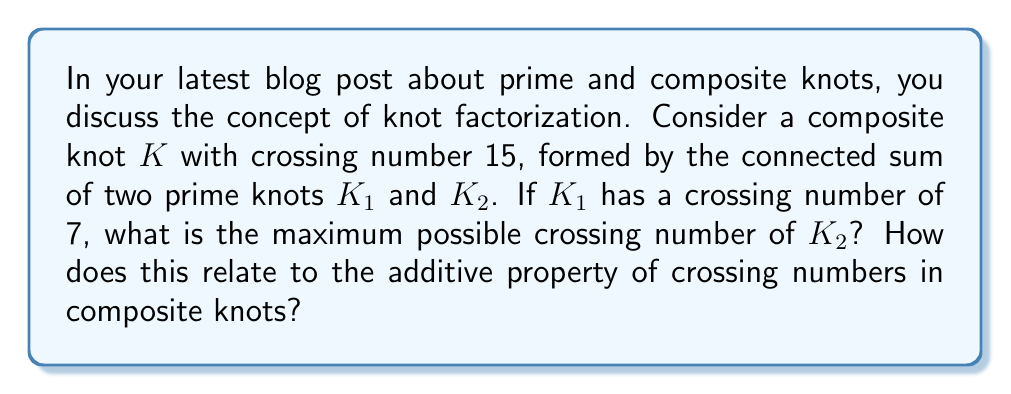What is the answer to this math problem? Let's approach this step-by-step:

1) First, recall the definition of a composite knot: A knot $K$ is composite if it can be expressed as the connected sum of two non-trivial knots $K_1$ and $K_2$.

2) A key property of crossing numbers in composite knots is that they are additive. This means:

   $$c(K) \leq c(K_1) + c(K_2)$$

   where $c(K)$ denotes the crossing number of knot $K$.

3) In this case, we're given that:
   
   $$c(K) = 15$$
   $$c(K_1) = 7$$

4) We need to find the maximum possible value for $c(K_2)$. Using the additive property:

   $$15 \leq 7 + c(K_2)$$

5) Solving for $c(K_2)$:

   $$c(K_2) \leq 15 - 7 = 8$$

6) Therefore, the maximum possible crossing number for $K_2$ is 8.

7) This demonstrates the additive property of crossing numbers in composite knots: the crossing number of the composite knot (15) is equal to the sum of the crossing numbers of its prime components (7 + 8).
Answer: 8 